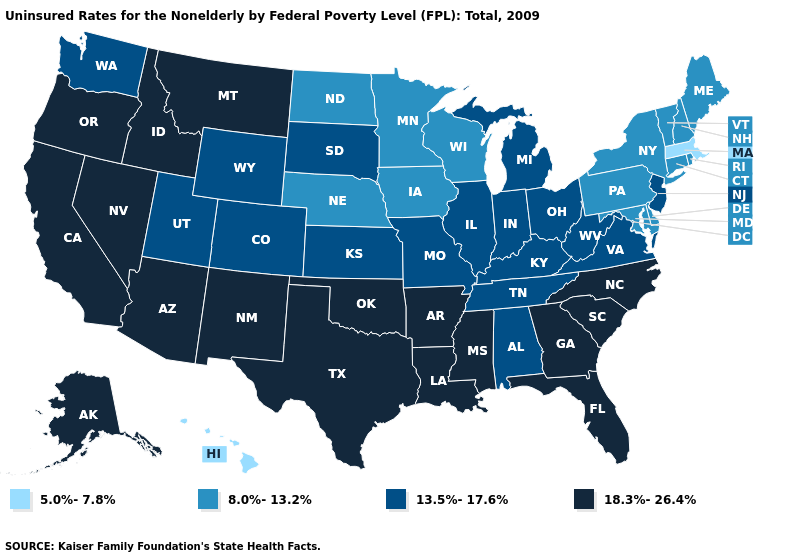Does the map have missing data?
Be succinct. No. What is the lowest value in the USA?
Give a very brief answer. 5.0%-7.8%. Name the states that have a value in the range 5.0%-7.8%?
Concise answer only. Hawaii, Massachusetts. Among the states that border Rhode Island , which have the lowest value?
Concise answer only. Massachusetts. What is the highest value in the South ?
Short answer required. 18.3%-26.4%. Name the states that have a value in the range 5.0%-7.8%?
Short answer required. Hawaii, Massachusetts. What is the value of Georgia?
Concise answer only. 18.3%-26.4%. Which states hav the highest value in the MidWest?
Keep it brief. Illinois, Indiana, Kansas, Michigan, Missouri, Ohio, South Dakota. Name the states that have a value in the range 18.3%-26.4%?
Short answer required. Alaska, Arizona, Arkansas, California, Florida, Georgia, Idaho, Louisiana, Mississippi, Montana, Nevada, New Mexico, North Carolina, Oklahoma, Oregon, South Carolina, Texas. What is the value of Colorado?
Give a very brief answer. 13.5%-17.6%. How many symbols are there in the legend?
Give a very brief answer. 4. What is the value of Minnesota?
Keep it brief. 8.0%-13.2%. Name the states that have a value in the range 8.0%-13.2%?
Keep it brief. Connecticut, Delaware, Iowa, Maine, Maryland, Minnesota, Nebraska, New Hampshire, New York, North Dakota, Pennsylvania, Rhode Island, Vermont, Wisconsin. Name the states that have a value in the range 8.0%-13.2%?
Give a very brief answer. Connecticut, Delaware, Iowa, Maine, Maryland, Minnesota, Nebraska, New Hampshire, New York, North Dakota, Pennsylvania, Rhode Island, Vermont, Wisconsin. Does Oklahoma have the highest value in the USA?
Answer briefly. Yes. 